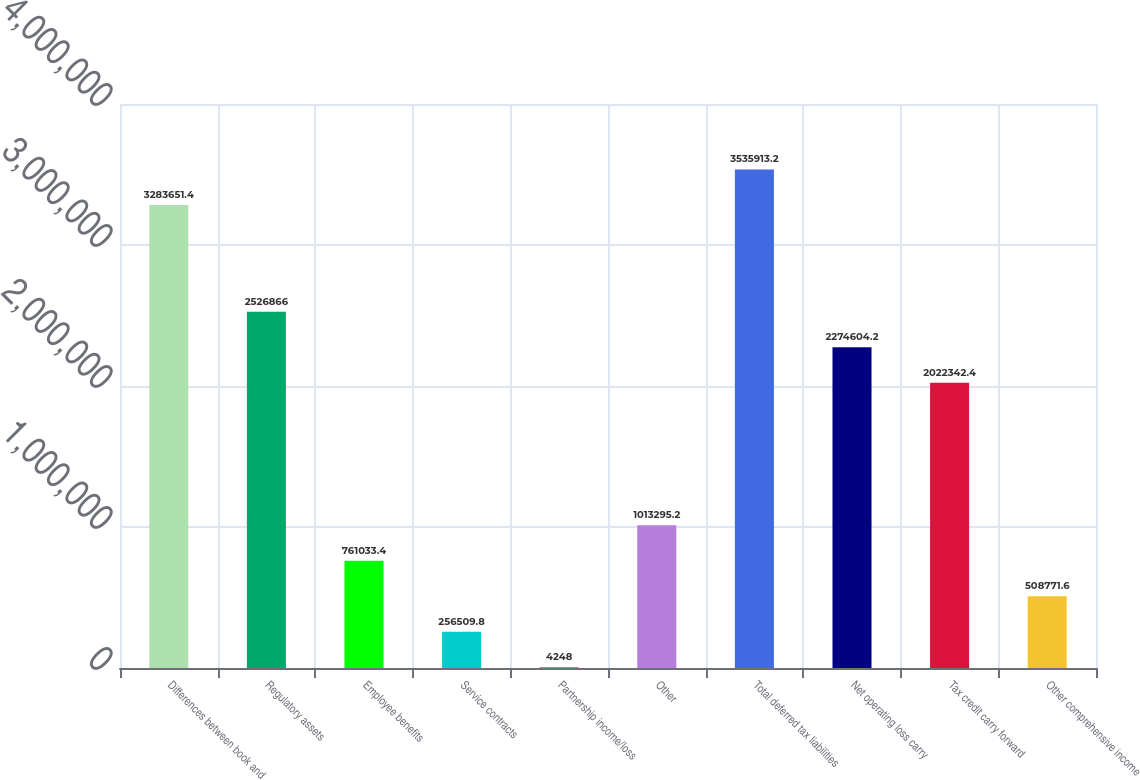Convert chart. <chart><loc_0><loc_0><loc_500><loc_500><bar_chart><fcel>Differences between book and<fcel>Regulatory assets<fcel>Employee benefits<fcel>Service contracts<fcel>Partnership income/loss<fcel>Other<fcel>Total deferred tax liabilities<fcel>Net operating loss carry<fcel>Tax credit carry forward<fcel>Other comprehensive income<nl><fcel>3.28365e+06<fcel>2.52687e+06<fcel>761033<fcel>256510<fcel>4248<fcel>1.0133e+06<fcel>3.53591e+06<fcel>2.2746e+06<fcel>2.02234e+06<fcel>508772<nl></chart> 